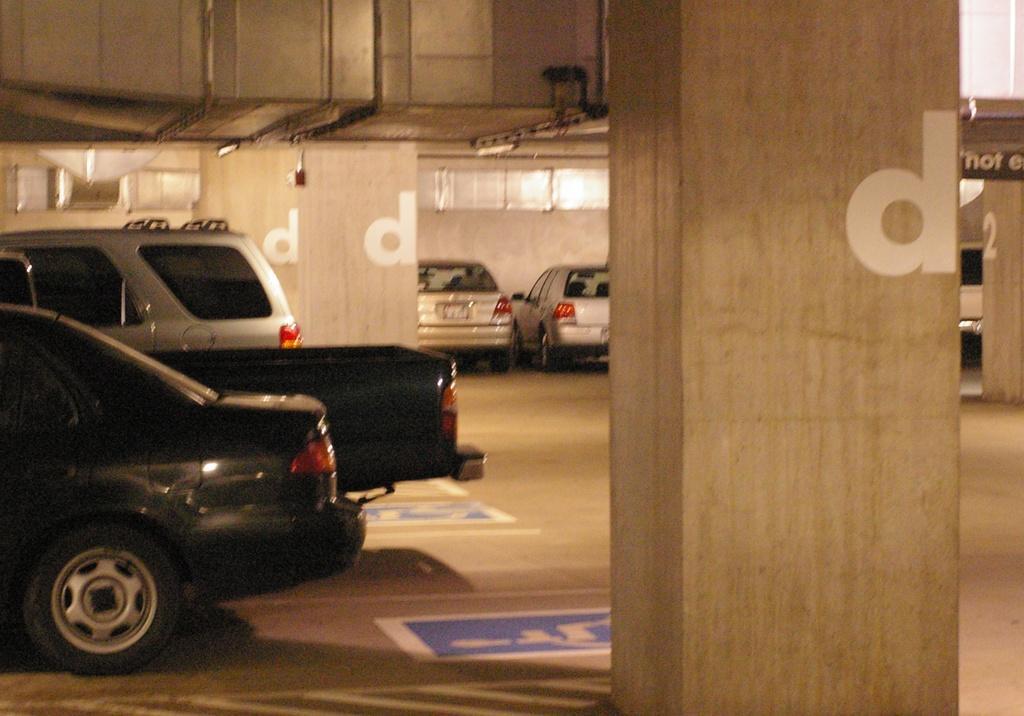Can you describe this image briefly? In this picture I can see few vehicles on the left side. In the middle there are pillars, it looks like a cellar. 